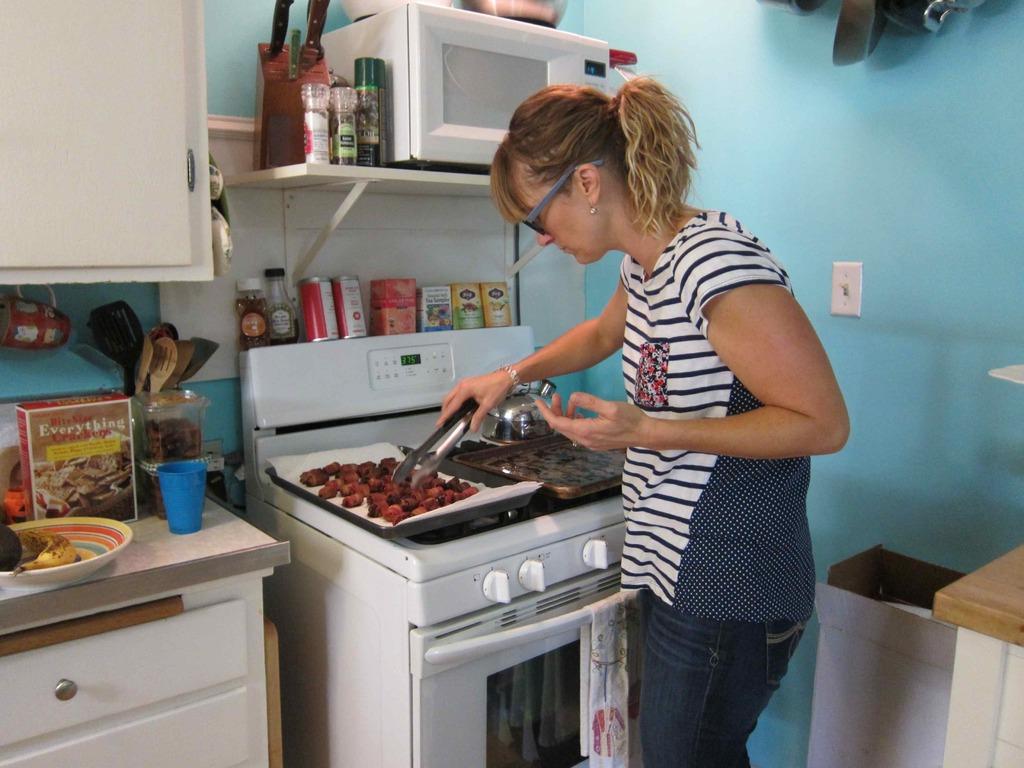What does the large box on the left of the counter say in white text?
Offer a terse response. Everything. 